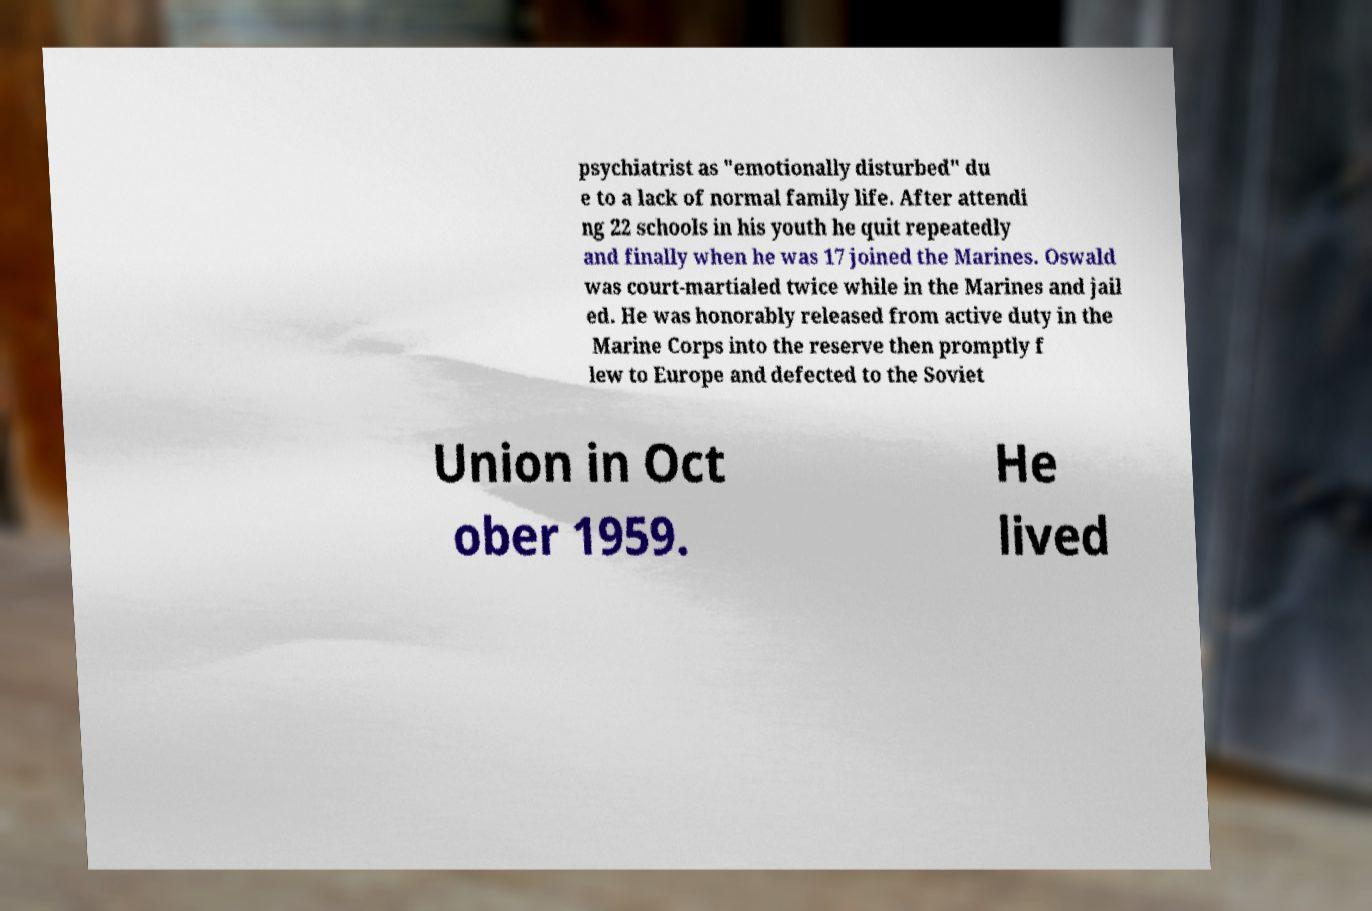Please read and relay the text visible in this image. What does it say? psychiatrist as "emotionally disturbed" du e to a lack of normal family life. After attendi ng 22 schools in his youth he quit repeatedly and finally when he was 17 joined the Marines. Oswald was court-martialed twice while in the Marines and jail ed. He was honorably released from active duty in the Marine Corps into the reserve then promptly f lew to Europe and defected to the Soviet Union in Oct ober 1959. He lived 